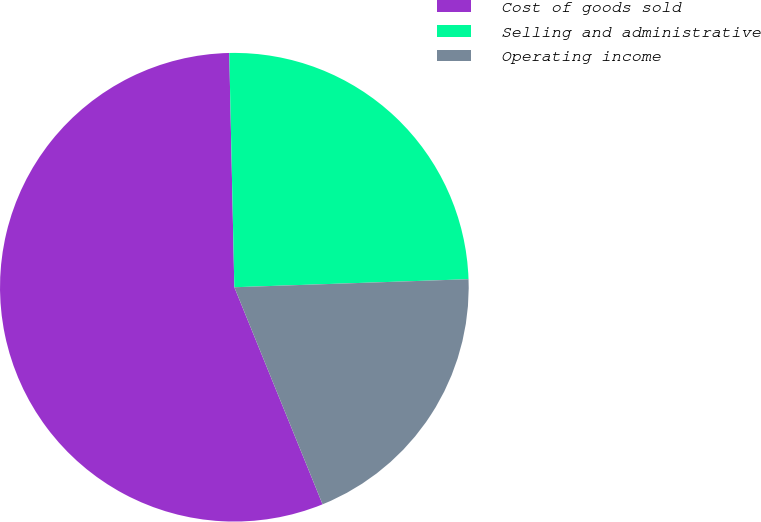Convert chart. <chart><loc_0><loc_0><loc_500><loc_500><pie_chart><fcel>Cost of goods sold<fcel>Selling and administrative<fcel>Operating income<nl><fcel>55.8%<fcel>24.8%<fcel>19.4%<nl></chart> 